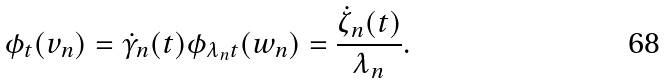<formula> <loc_0><loc_0><loc_500><loc_500>\phi _ { t } ( v _ { n } ) = \dot { \gamma } _ { n } ( t ) \phi _ { \lambda _ { n } t } ( w _ { n } ) = \frac { \dot { \zeta } _ { n } ( t ) } { \lambda _ { n } } .</formula> 